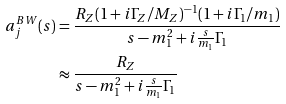<formula> <loc_0><loc_0><loc_500><loc_500>a _ { j } ^ { B W } ( s ) & = \frac { R _ { Z } ( 1 + i \Gamma _ { Z } / M _ { Z } ) ^ { - 1 } ( 1 + i \Gamma _ { 1 } / m _ { 1 } ) } { s - m _ { 1 } ^ { 2 } + i \frac { s } { m _ { 1 } } \Gamma _ { 1 } } \\ & \approx \frac { R _ { Z } } { s - m _ { 1 } ^ { 2 } + i \frac { s } { m _ { 1 } } \Gamma _ { 1 } }</formula> 